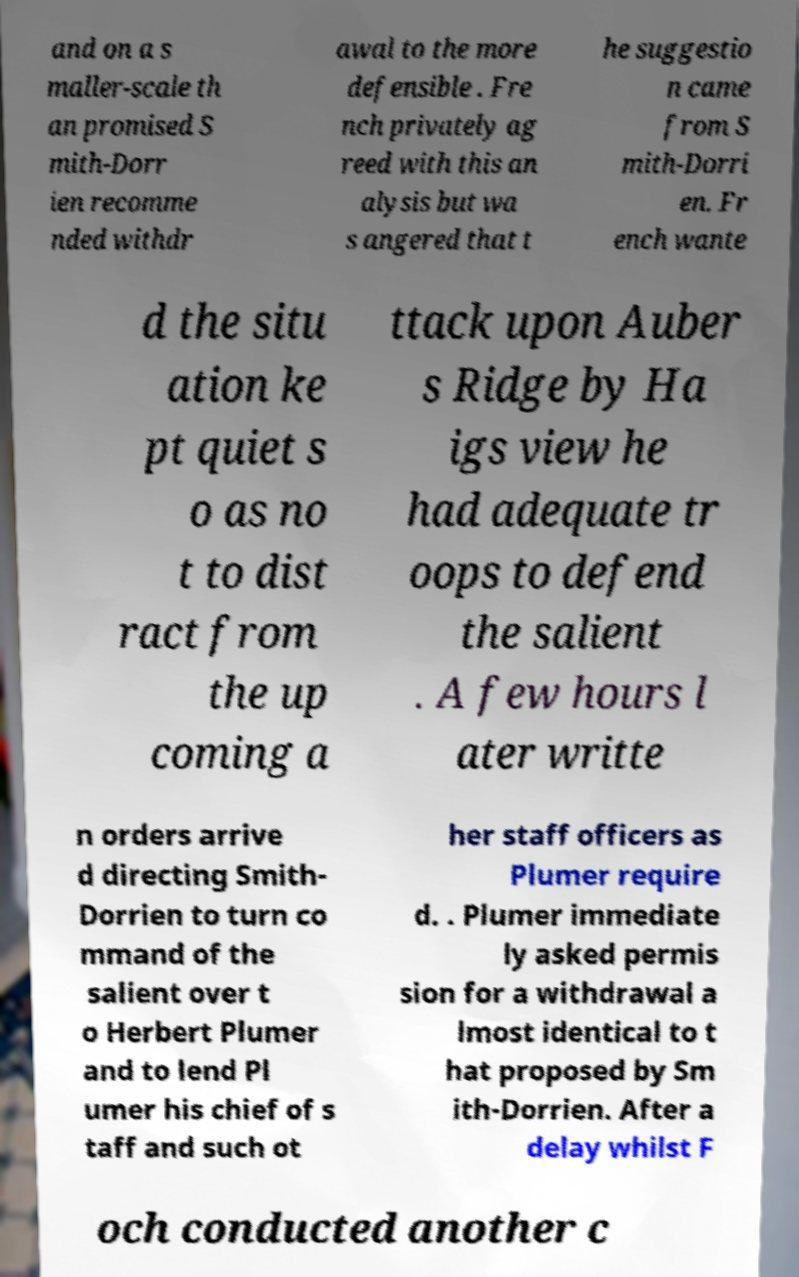What messages or text are displayed in this image? I need them in a readable, typed format. and on a s maller-scale th an promised S mith-Dorr ien recomme nded withdr awal to the more defensible . Fre nch privately ag reed with this an alysis but wa s angered that t he suggestio n came from S mith-Dorri en. Fr ench wante d the situ ation ke pt quiet s o as no t to dist ract from the up coming a ttack upon Auber s Ridge by Ha igs view he had adequate tr oops to defend the salient . A few hours l ater writte n orders arrive d directing Smith- Dorrien to turn co mmand of the salient over t o Herbert Plumer and to lend Pl umer his chief of s taff and such ot her staff officers as Plumer require d. . Plumer immediate ly asked permis sion for a withdrawal a lmost identical to t hat proposed by Sm ith-Dorrien. After a delay whilst F och conducted another c 